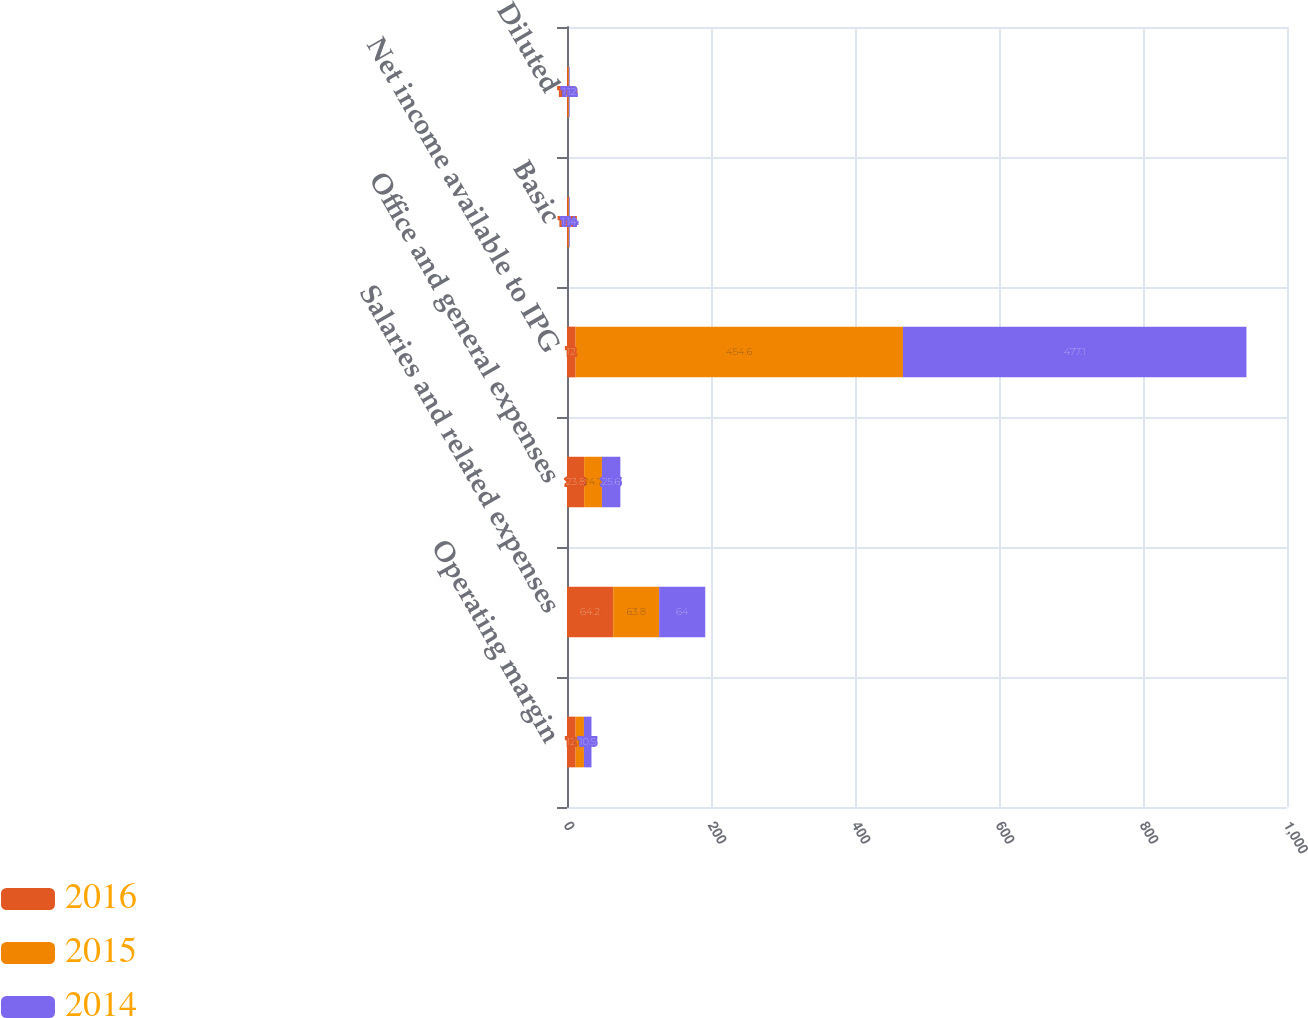Convert chart. <chart><loc_0><loc_0><loc_500><loc_500><stacked_bar_chart><ecel><fcel>Operating margin<fcel>Salaries and related expenses<fcel>Office and general expenses<fcel>Net income available to IPG<fcel>Basic<fcel>Diluted<nl><fcel>2016<fcel>12<fcel>64.2<fcel>23.8<fcel>12<fcel>1.53<fcel>1.49<nl><fcel>2015<fcel>11.5<fcel>63.8<fcel>24.7<fcel>454.6<fcel>1.11<fcel>1.09<nl><fcel>2014<fcel>10.5<fcel>64<fcel>25.6<fcel>477.1<fcel>1.14<fcel>1.12<nl></chart> 